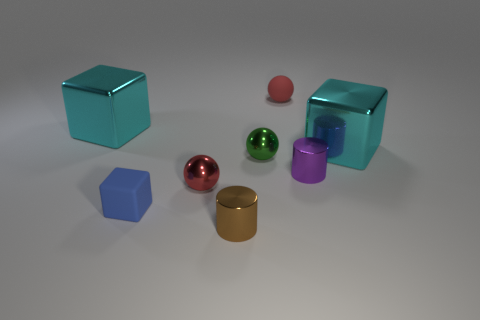Are there any patterns or similarities among the objects that might suggest a set? Based on the image, the objects can be grouped by shapes—there are spheres, cubes, and cylinders. Each category itself doesn't form a complete set, but the similarities in shape among certain objects and differences in colors and materials suggest they might be part of a collection meant for sorting or grouping in an educational or design context. 